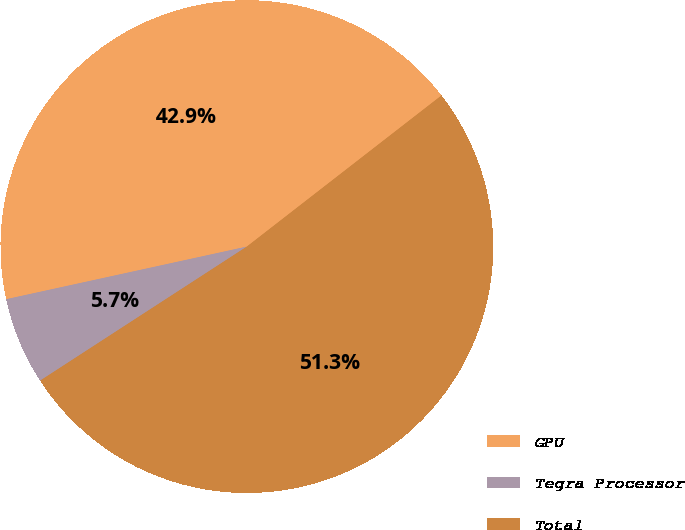<chart> <loc_0><loc_0><loc_500><loc_500><pie_chart><fcel>GPU<fcel>Tegra Processor<fcel>Total<nl><fcel>42.92%<fcel>5.73%<fcel>51.35%<nl></chart> 